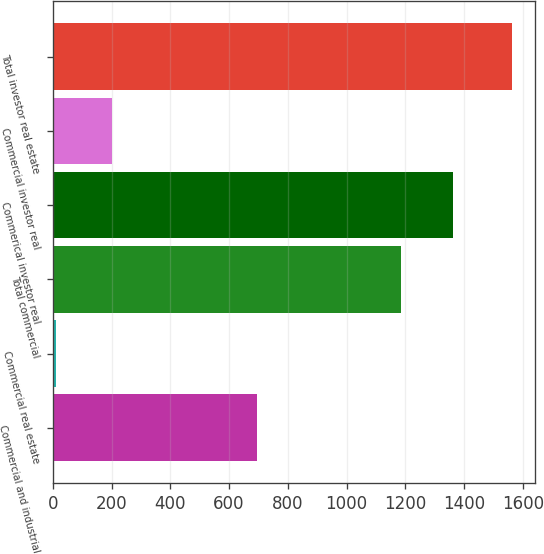<chart> <loc_0><loc_0><loc_500><loc_500><bar_chart><fcel>Commercial and industrial<fcel>Commercial real estate<fcel>Total commercial<fcel>Commerical investor real<fcel>Commercial investor real<fcel>Total investor real estate<nl><fcel>696.2<fcel>10<fcel>1185<fcel>1361<fcel>201<fcel>1562<nl></chart> 